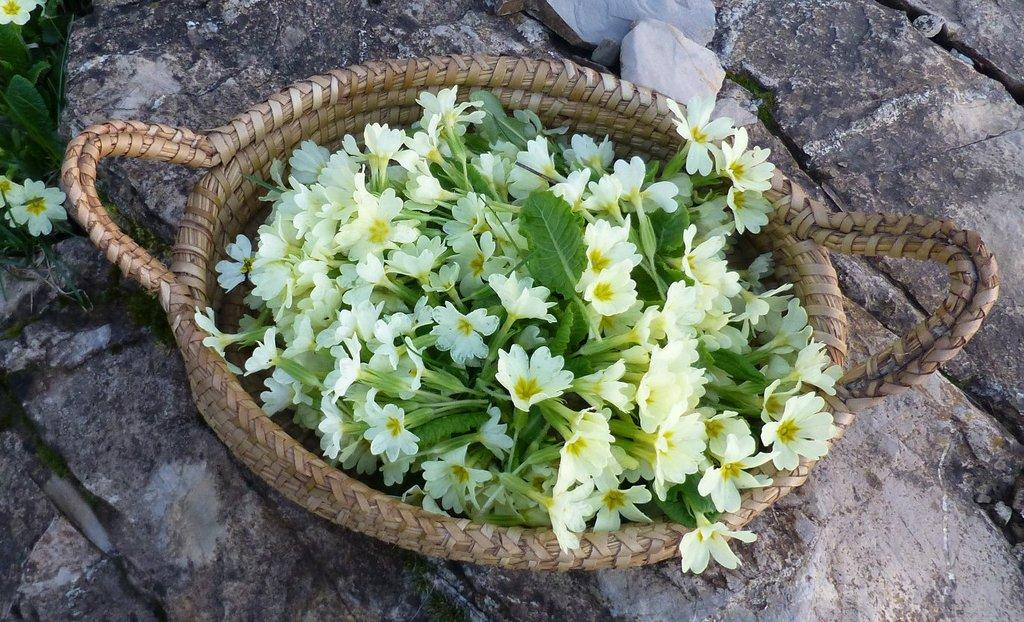What object is present in the image that can hold items? There is a basket in the image. What is the color of the basket? The basket is light brown in color. What type of decorations are on the basket? There are white flowers and leaves on the basket. What can be seen beneath the basket in the image? The surface beneath the basket is visible in the image. Are there any other flowers or leaves in the image besides those on the basket? Yes, there are additional flowers and leaves in the image. What type of guitar is being played by the goat in the image? There is no guitar or goat present in the image; it features a basket with flowers and leaves. What is the goat using to carry the sack in the image? There is no goat or sack present in the image. 